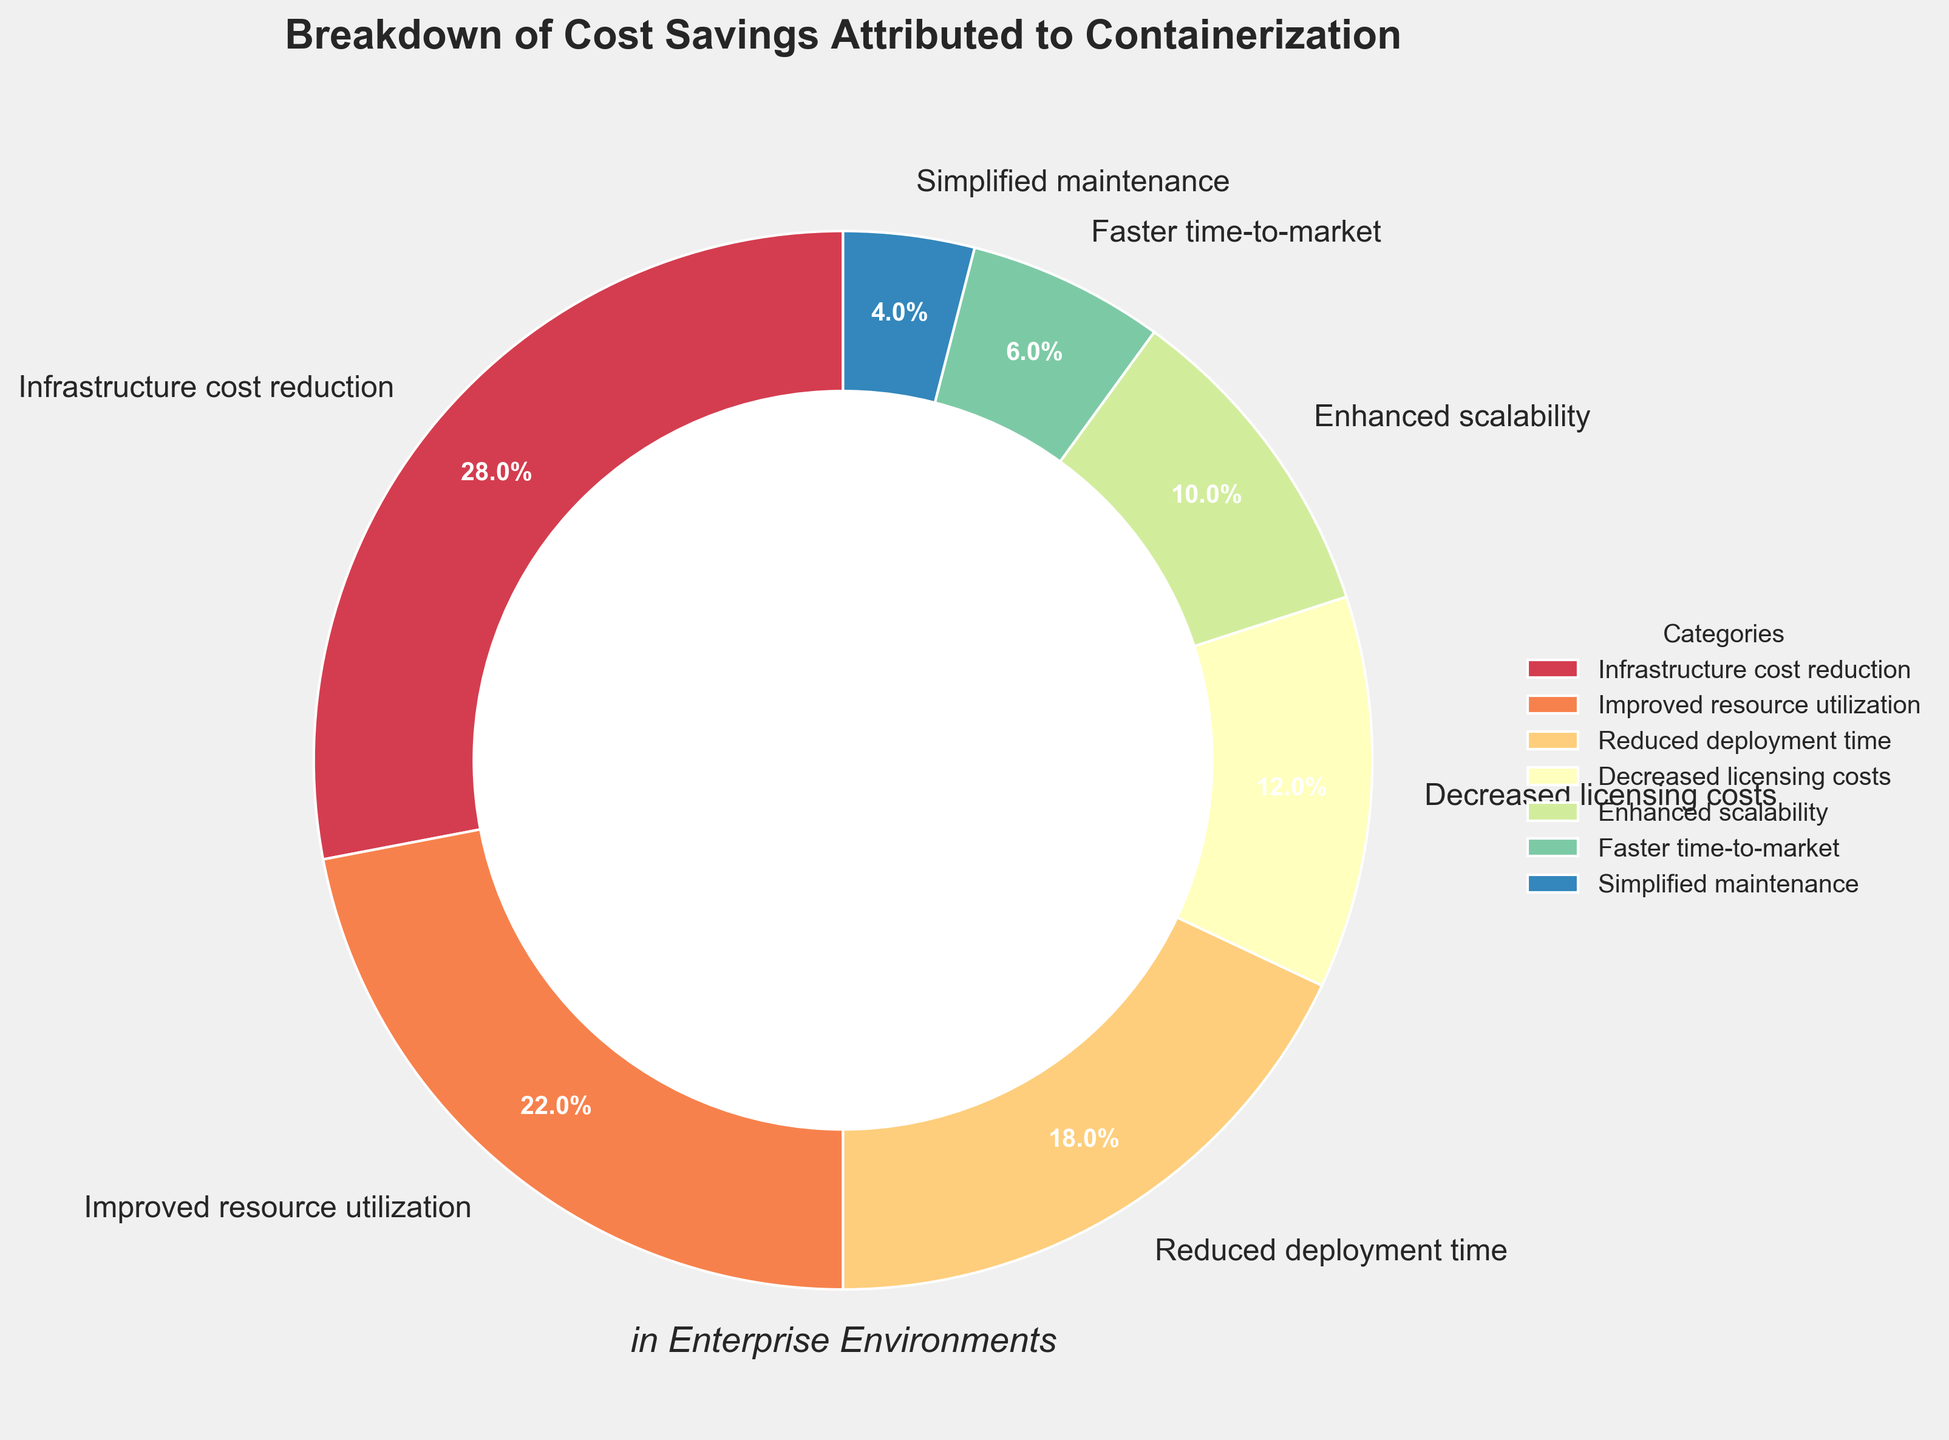Which category has the largest portion of cost savings attributed to containerization? The largest portion of the pie chart is labeled "Infrastructure cost reduction," which occupies the most significant part visually and shows 28%.
Answer: Infrastructure cost reduction Which category has the smallest portion of cost savings attributed to containerization? The smallest portion of the pie chart is labeled "Simplified maintenance," which occupies the smallest part visually and shows 4%.
Answer: Simplified maintenance What is the combined percentage of "Reduced deployment time" and "Decreased licensing costs"? "Reduced deployment time" has 18% and "Decreased licensing costs" has 12%. Adding them together: 18% + 12% = 30%.
Answer: 30% How does the percentage of "Improved resource utilization" compare to "Enhanced scalability"? "Improved resource utilization" is 22%, which is greater than "Enhanced scalability," which is 10%.
Answer: Improved resource utilization is greater Which three categories combined contribute to more than 50% of the cost savings? Adding the percentages of the three largest categories: "Infrastructure cost reduction" (28%), "Improved resource utilization" (22%), and "Reduced deployment time" (18%), which sums up to 28% + 22% + 18% = 68%. This is more than 50%.
Answer: Infrastructure cost reduction, Improved resource utilization, Reduced deployment time Does "Decreased licensing costs" or "Faster time-to-market" contribute more to cost savings? The percentage for "Decreased licensing costs" is 12% and for "Faster time-to-market" is 6%. So, "Decreased licensing costs" contributes more.
Answer: Decreased licensing costs What is the difference in the percentage contribution between "Infrastructure cost reduction" and "Improved resource utilization"? "Infrastructure cost reduction" is 28% and "Improved resource utilization" is 22%. The difference is calculated as 28% - 22% = 6%.
Answer: 6% What is the percentage contribution of categories labelled "Infrastructure cost reduction", "Improved resource utilization", and "Enhanced scalability" combined? Adding their percentages: "Infrastructure cost reduction" (28%), "Improved resource utilization" (22%), and "Enhanced scalability" (10%). The combined contribution is 28% + 22% + 10% = 60%.
Answer: 60% What is the visual impact of adding a center circle to the pie chart? The center circle turns the pie chart into a donut chart, which visually emphasizes the proportions and makes it easier to compare the relative sizes of different categories.
Answer: Emphasizes proportions and facilitates comparison Which category's wedge is colored most differently compared to the others in the pie chart? Each wedge has a distinct color palette from the colormap, but visually, the "Infrastructure cost reduction" uses a unique, bright color making it stand out more.
Answer: Infrastructure cost reduction 